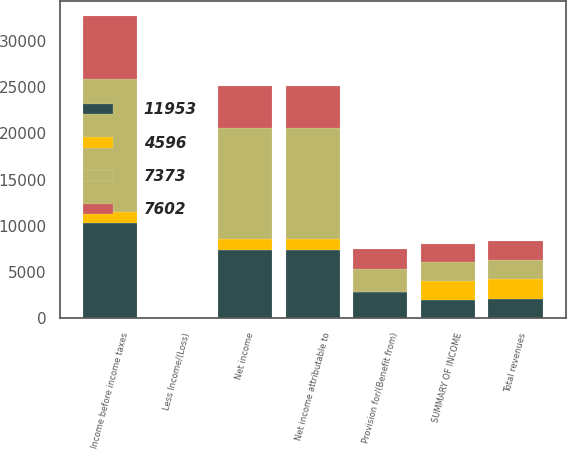Convert chart. <chart><loc_0><loc_0><loc_500><loc_500><stacked_bar_chart><ecel><fcel>SUMMARY OF INCOME<fcel>Total revenues<fcel>Income before income taxes<fcel>Provision for/(Benefit from)<fcel>Net income<fcel>Less Income/(Loss)<fcel>Net income attributable to<nl><fcel>7373<fcel>2013<fcel>2102.5<fcel>14371<fcel>2425<fcel>11946<fcel>7<fcel>11953<nl><fcel>4596<fcel>2014<fcel>2102.5<fcel>1234<fcel>4<fcel>1230<fcel>1<fcel>1231<nl><fcel>11953<fcel>2015<fcel>2102.5<fcel>10252<fcel>2881<fcel>7371<fcel>2<fcel>7373<nl><fcel>7602<fcel>2016<fcel>2102.5<fcel>6796<fcel>2189<fcel>4607<fcel>11<fcel>4596<nl></chart> 